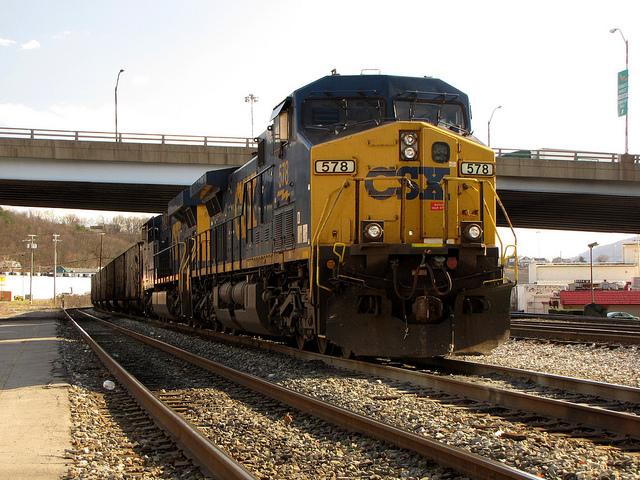Is this a passenger train?
Give a very brief answer. No. Does the train have a lot of clearance below the highway?
Short answer required. No. What color is the train?
Answer briefly. Yellow. 